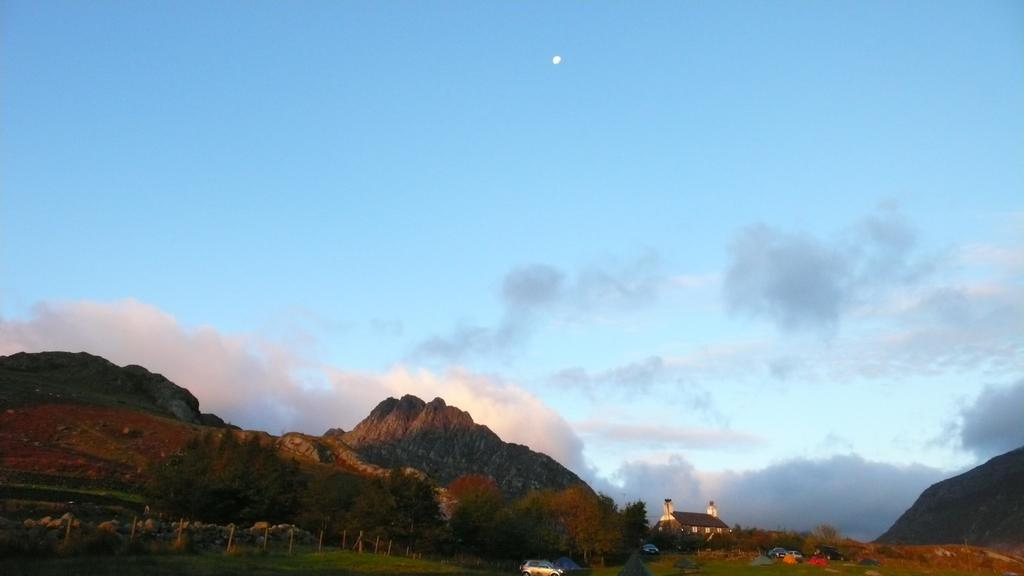What type of structure is present in the image? There is a house in the image. Can you describe the house's features? The house has a roof and windows. What else can be seen on the ground in the image? There are vehicles and stones on the ground in the image. What are the poles used for in the image? The purpose of the poles is not specified in the image. What natural features are visible in the image? The hills and the moon are visible in the image. How would you describe the sky in the image? The sky is cloudy in the image. What type of stew is being prepared on the ground in the image? There is no stew present in the image; it features a house, vehicles, stones, poles, hills, the moon, and a cloudy sky. 